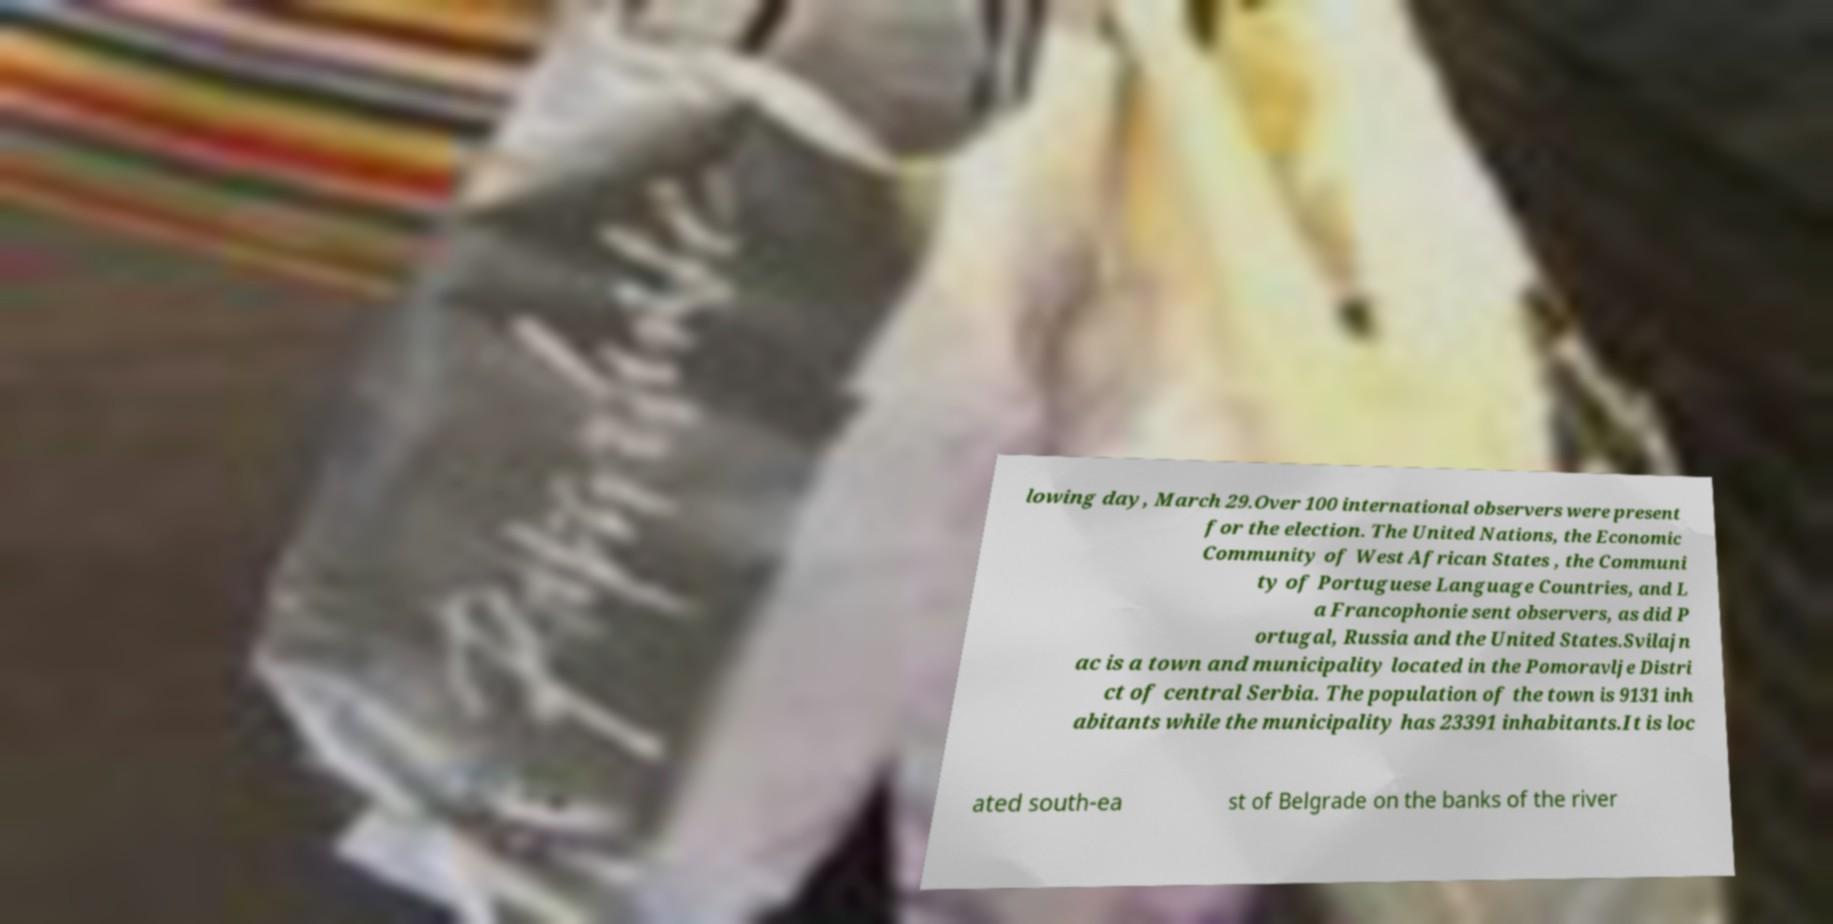Please identify and transcribe the text found in this image. lowing day, March 29.Over 100 international observers were present for the election. The United Nations, the Economic Community of West African States , the Communi ty of Portuguese Language Countries, and L a Francophonie sent observers, as did P ortugal, Russia and the United States.Svilajn ac is a town and municipality located in the Pomoravlje Distri ct of central Serbia. The population of the town is 9131 inh abitants while the municipality has 23391 inhabitants.It is loc ated south-ea st of Belgrade on the banks of the river 